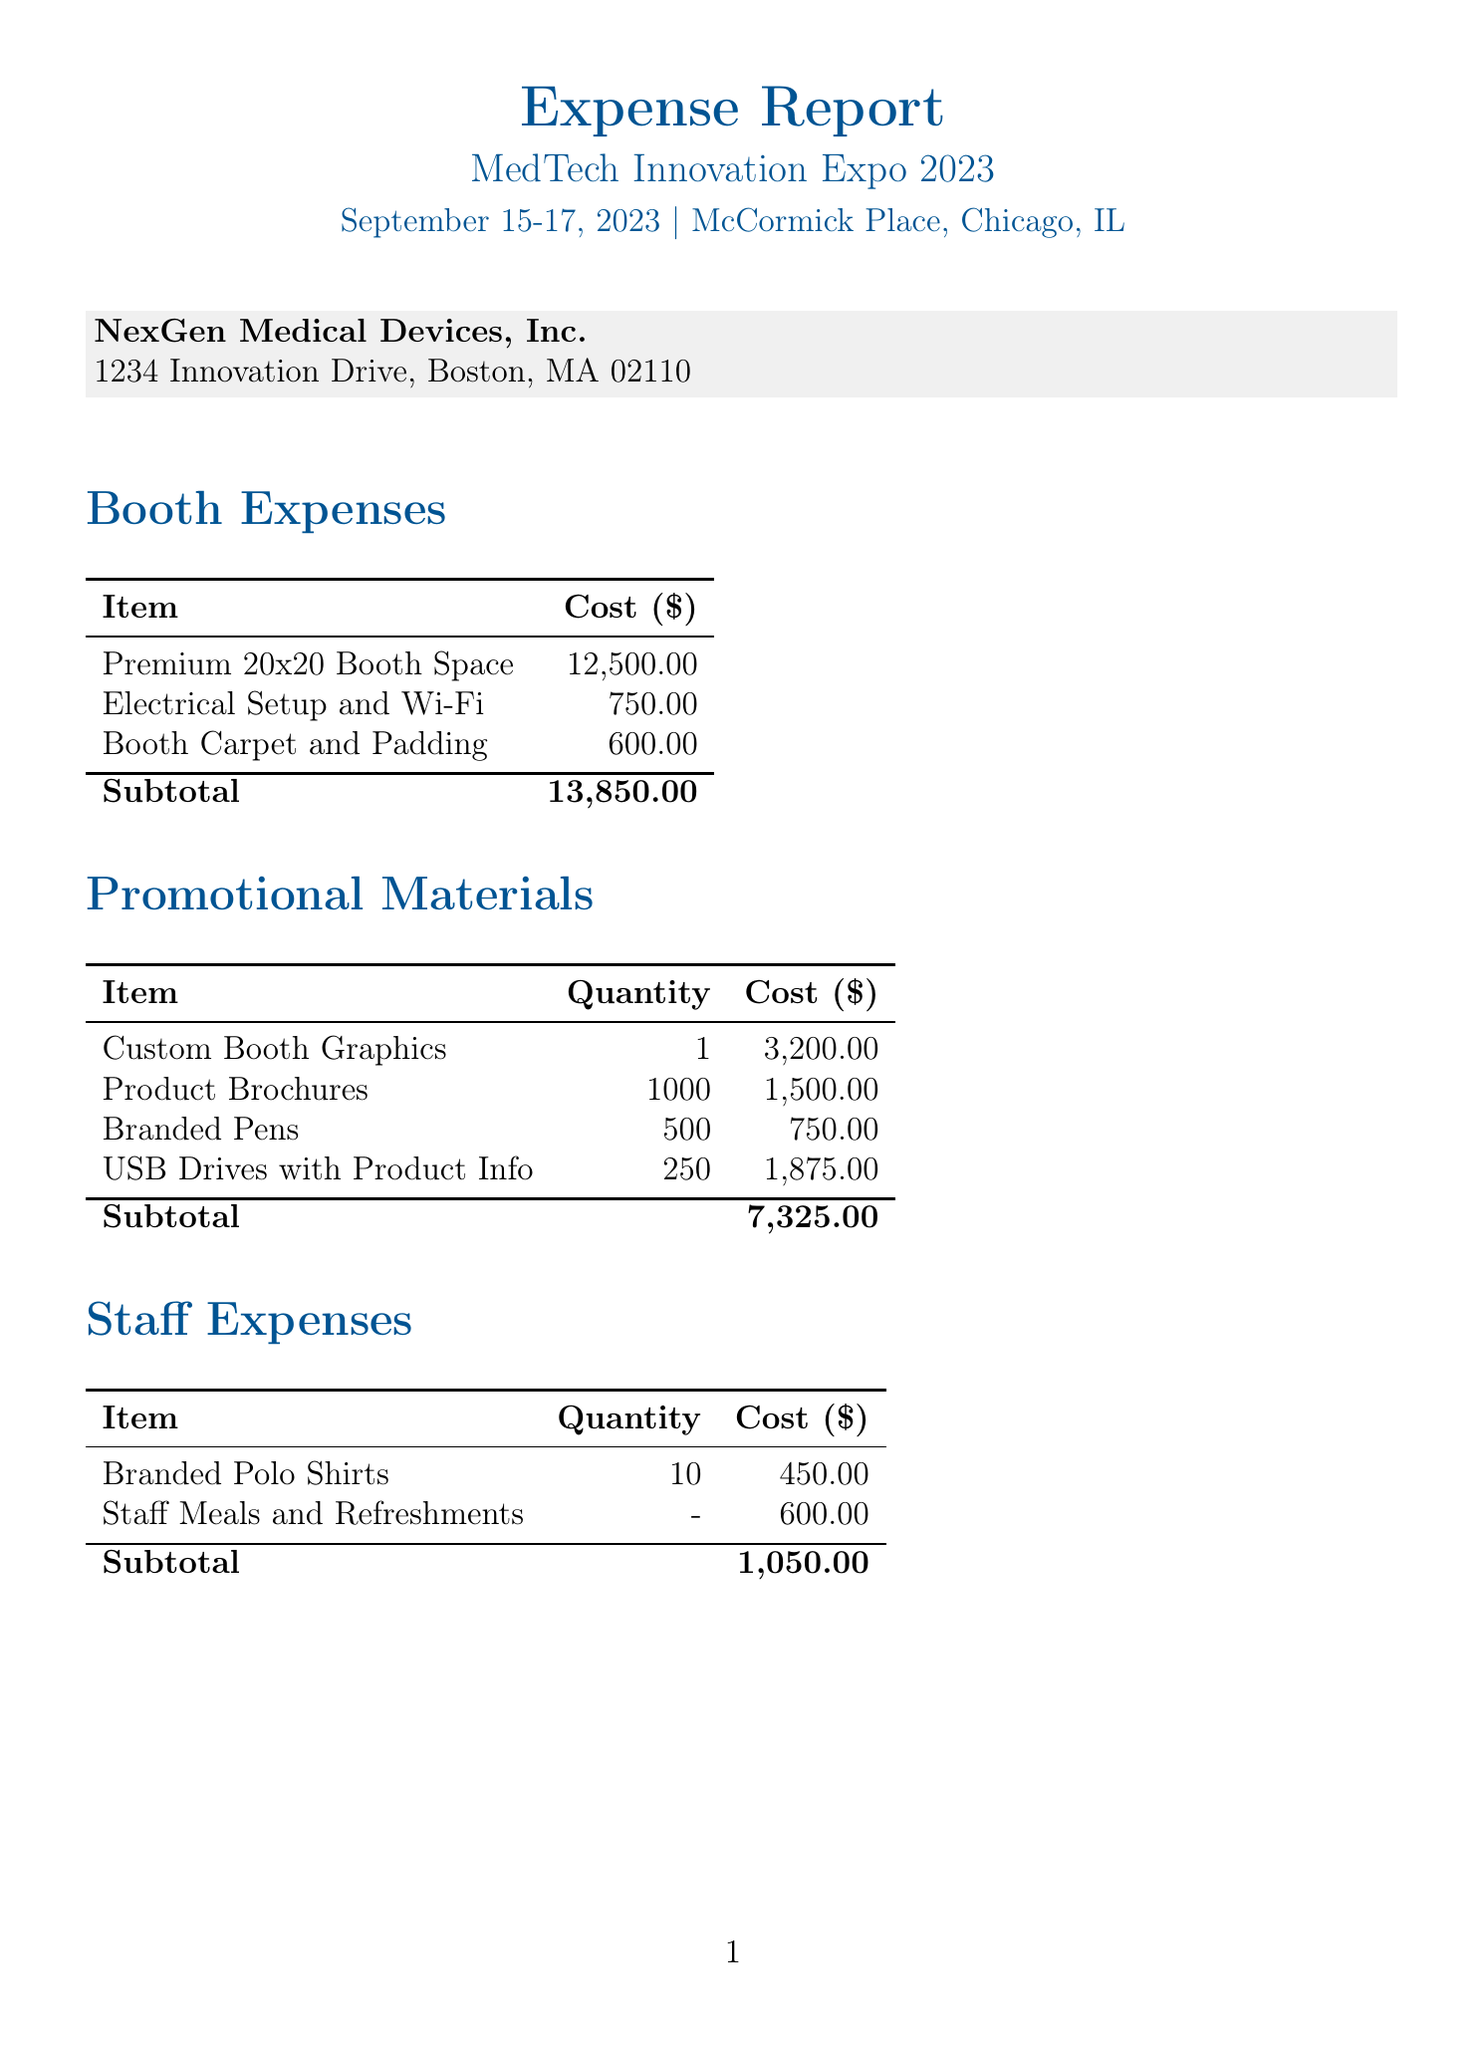What is the event name? The document specifies the event as "MedTech Innovation Expo 2023."
Answer: MedTech Innovation Expo 2023 What is the total expense? The total expense is displayed as "$24,425.00" at the bottom of the document.
Answer: $24,425.00 Who approved the expenses? The receipt states that the expenses were approved by "Dr. Sarah Johnson, VP of Marketing."
Answer: Dr. Sarah Johnson What is the location of the trade show? The document indicates that the trade show took place at "McCormick Place, Chicago, IL."
Answer: McCormick Place, Chicago, IL How much did the booth space cost? The cost for the "Premium 20x20 Booth Space" is listed as "$12,500.00."
Answer: $12,500.00 What was the cost of promotional materials? To find the subtotal, you need to sum all costs under "Promotional Materials," which totals "$7,325.00."
Answer: $7,325.00 How many USB drives were ordered? The document shows that "250" USB drives were ordered.
Answer: 250 What type of payment method was used? The expense report indicates the payment method as a "Corporate American Express Card."
Answer: Corporate American Express Card What is a note related to the expenses? The document notes that "Expenses aligned with Q3 marketing budget for new cardiovascular monitoring device launch."
Answer: Expenses aligned with Q3 marketing budget for new cardiovascular monitoring device launch 